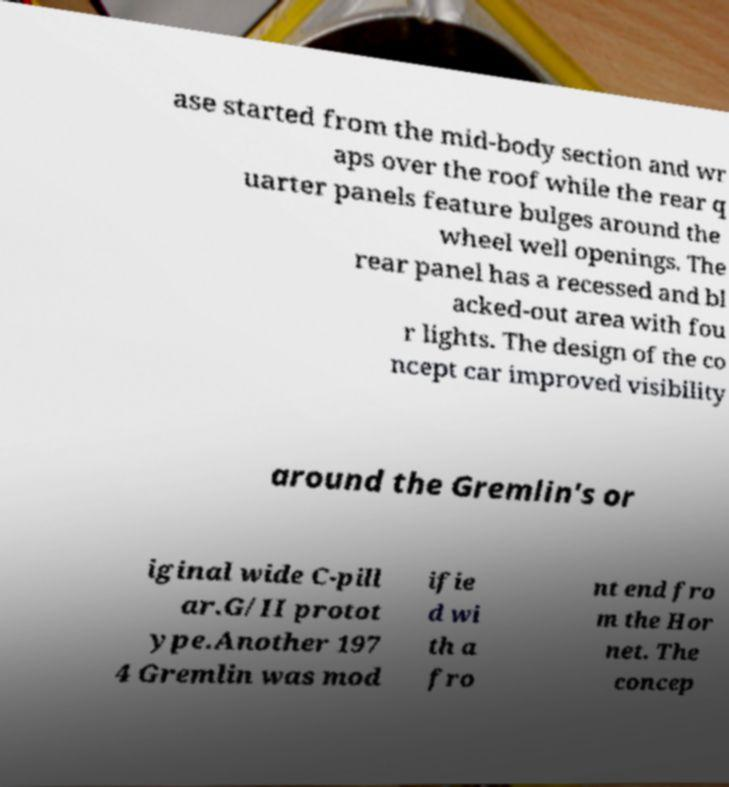Can you read and provide the text displayed in the image?This photo seems to have some interesting text. Can you extract and type it out for me? ase started from the mid-body section and wr aps over the roof while the rear q uarter panels feature bulges around the wheel well openings. The rear panel has a recessed and bl acked-out area with fou r lights. The design of the co ncept car improved visibility around the Gremlin's or iginal wide C-pill ar.G/II protot ype.Another 197 4 Gremlin was mod ifie d wi th a fro nt end fro m the Hor net. The concep 